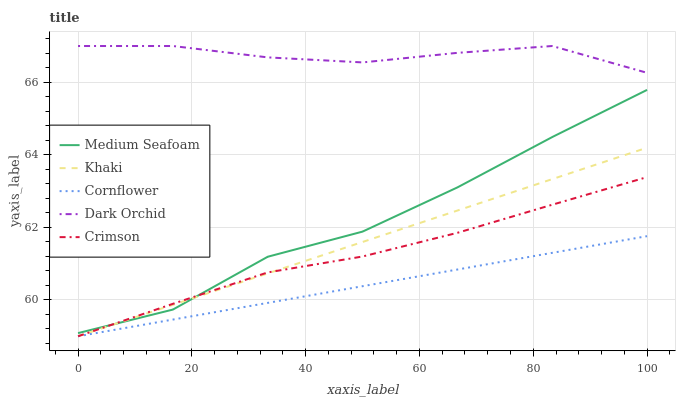Does Cornflower have the minimum area under the curve?
Answer yes or no. Yes. Does Dark Orchid have the maximum area under the curve?
Answer yes or no. Yes. Does Khaki have the minimum area under the curve?
Answer yes or no. No. Does Khaki have the maximum area under the curve?
Answer yes or no. No. Is Cornflower the smoothest?
Answer yes or no. Yes. Is Medium Seafoam the roughest?
Answer yes or no. Yes. Is Khaki the smoothest?
Answer yes or no. No. Is Khaki the roughest?
Answer yes or no. No. Does Crimson have the lowest value?
Answer yes or no. Yes. Does Medium Seafoam have the lowest value?
Answer yes or no. No. Does Dark Orchid have the highest value?
Answer yes or no. Yes. Does Khaki have the highest value?
Answer yes or no. No. Is Cornflower less than Dark Orchid?
Answer yes or no. Yes. Is Dark Orchid greater than Medium Seafoam?
Answer yes or no. Yes. Does Cornflower intersect Crimson?
Answer yes or no. Yes. Is Cornflower less than Crimson?
Answer yes or no. No. Is Cornflower greater than Crimson?
Answer yes or no. No. Does Cornflower intersect Dark Orchid?
Answer yes or no. No. 